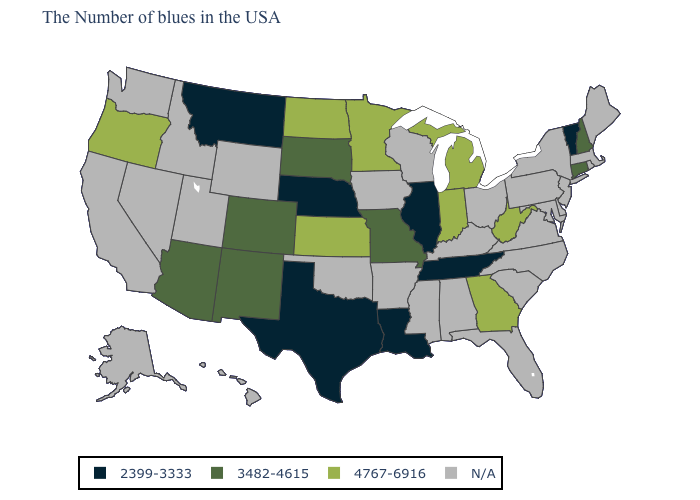What is the highest value in the USA?
Give a very brief answer. 4767-6916. Among the states that border Montana , which have the highest value?
Answer briefly. North Dakota. Which states have the lowest value in the USA?
Write a very short answer. Vermont, Tennessee, Illinois, Louisiana, Nebraska, Texas, Montana. What is the value of Wisconsin?
Answer briefly. N/A. What is the value of Louisiana?
Quick response, please. 2399-3333. Among the states that border Mississippi , which have the lowest value?
Quick response, please. Tennessee, Louisiana. What is the lowest value in the West?
Write a very short answer. 2399-3333. Does Montana have the lowest value in the West?
Write a very short answer. Yes. How many symbols are there in the legend?
Give a very brief answer. 4. Which states have the lowest value in the Northeast?
Keep it brief. Vermont. What is the value of Missouri?
Be succinct. 3482-4615. What is the value of Michigan?
Be succinct. 4767-6916. Name the states that have a value in the range N/A?
Give a very brief answer. Maine, Massachusetts, Rhode Island, New York, New Jersey, Delaware, Maryland, Pennsylvania, Virginia, North Carolina, South Carolina, Ohio, Florida, Kentucky, Alabama, Wisconsin, Mississippi, Arkansas, Iowa, Oklahoma, Wyoming, Utah, Idaho, Nevada, California, Washington, Alaska, Hawaii. 